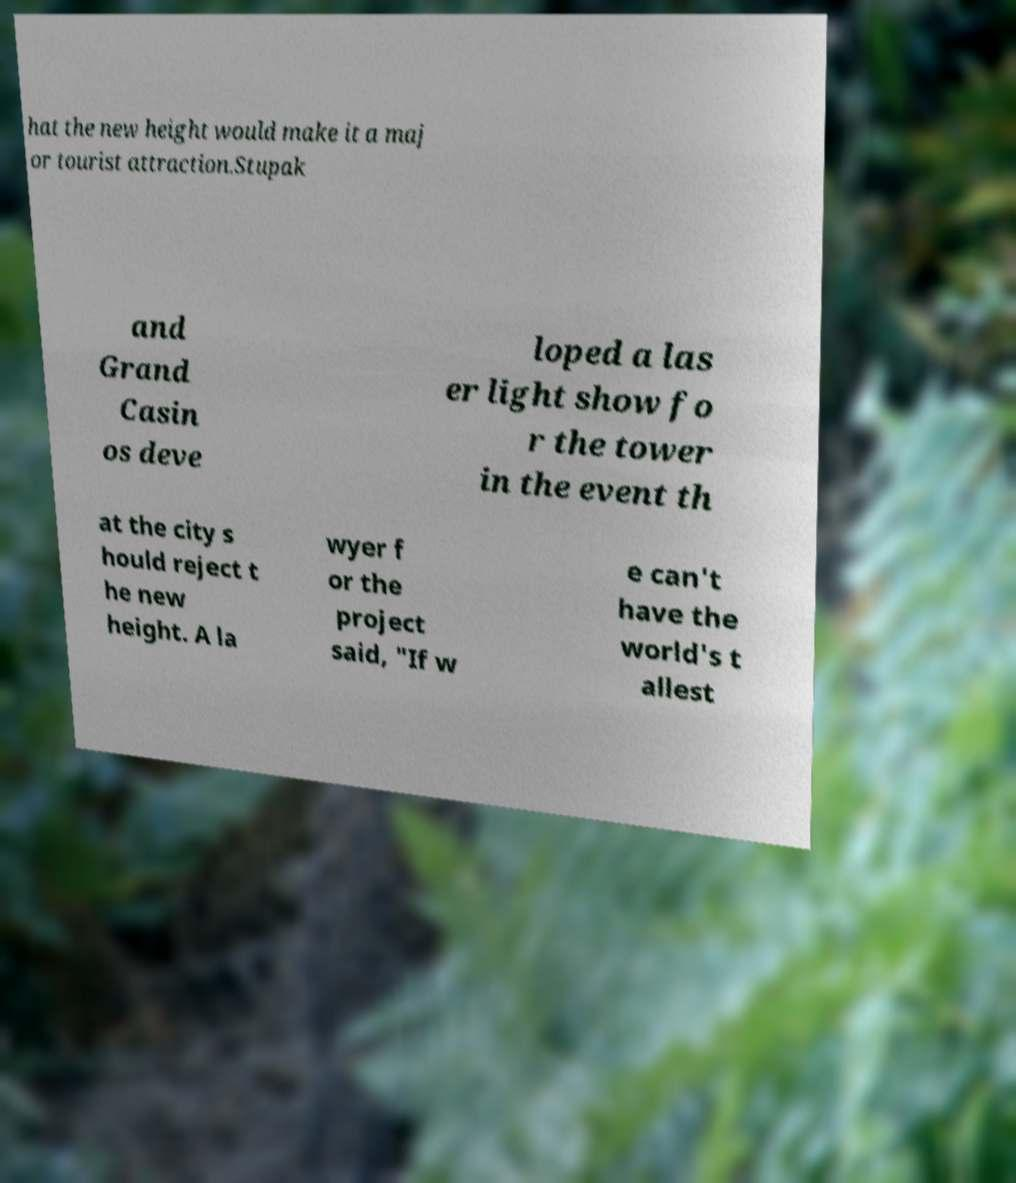Please identify and transcribe the text found in this image. hat the new height would make it a maj or tourist attraction.Stupak and Grand Casin os deve loped a las er light show fo r the tower in the event th at the city s hould reject t he new height. A la wyer f or the project said, "If w e can't have the world's t allest 